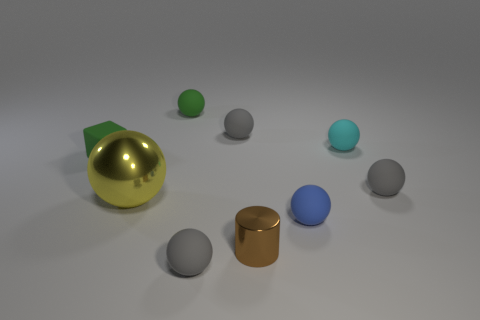How many other things are there of the same color as the large metal ball?
Provide a short and direct response. 0. Do the cyan rubber object and the blue rubber object have the same size?
Your answer should be compact. Yes. What number of objects are either large objects or small balls that are in front of the big yellow ball?
Offer a very short reply. 3. Are there fewer green things that are to the left of the green block than blue things left of the tiny blue thing?
Make the answer very short. No. What number of other things are there of the same material as the tiny green sphere
Offer a terse response. 6. There is a tiny metal cylinder to the left of the blue sphere; does it have the same color as the big metal ball?
Provide a succinct answer. No. There is a green rubber thing left of the large yellow ball; is there a cyan sphere in front of it?
Give a very brief answer. No. There is a gray thing that is in front of the small cyan ball and to the left of the small cyan ball; what material is it?
Ensure brevity in your answer.  Rubber. What is the shape of the other object that is made of the same material as the yellow thing?
Your answer should be compact. Cylinder. Is there any other thing that has the same shape as the blue object?
Your response must be concise. Yes. 